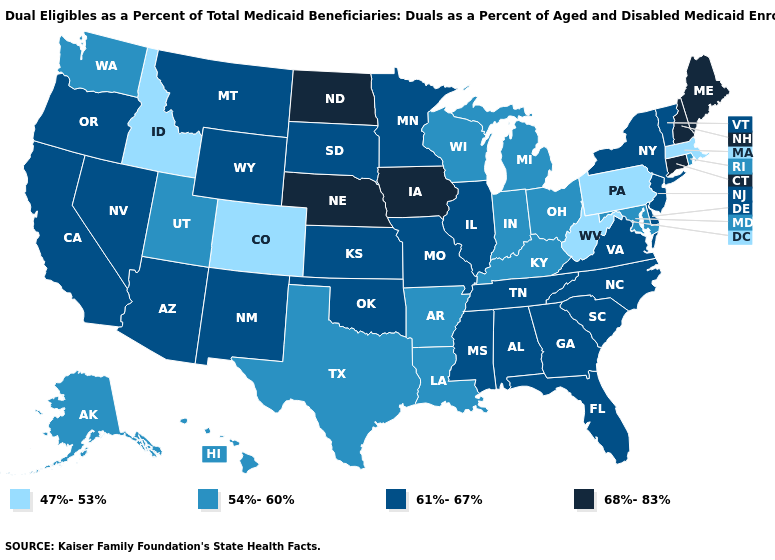What is the value of Connecticut?
Answer briefly. 68%-83%. What is the value of Mississippi?
Be succinct. 61%-67%. What is the lowest value in the MidWest?
Answer briefly. 54%-60%. Name the states that have a value in the range 54%-60%?
Keep it brief. Alaska, Arkansas, Hawaii, Indiana, Kentucky, Louisiana, Maryland, Michigan, Ohio, Rhode Island, Texas, Utah, Washington, Wisconsin. Does Maine have the highest value in the Northeast?
Concise answer only. Yes. Name the states that have a value in the range 68%-83%?
Concise answer only. Connecticut, Iowa, Maine, Nebraska, New Hampshire, North Dakota. What is the highest value in states that border Rhode Island?
Give a very brief answer. 68%-83%. Name the states that have a value in the range 68%-83%?
Give a very brief answer. Connecticut, Iowa, Maine, Nebraska, New Hampshire, North Dakota. What is the value of Wisconsin?
Keep it brief. 54%-60%. What is the highest value in the USA?
Be succinct. 68%-83%. What is the value of Iowa?
Be succinct. 68%-83%. Name the states that have a value in the range 54%-60%?
Keep it brief. Alaska, Arkansas, Hawaii, Indiana, Kentucky, Louisiana, Maryland, Michigan, Ohio, Rhode Island, Texas, Utah, Washington, Wisconsin. Does the map have missing data?
Give a very brief answer. No. Among the states that border Minnesota , which have the lowest value?
Keep it brief. Wisconsin. Which states have the highest value in the USA?
Quick response, please. Connecticut, Iowa, Maine, Nebraska, New Hampshire, North Dakota. 